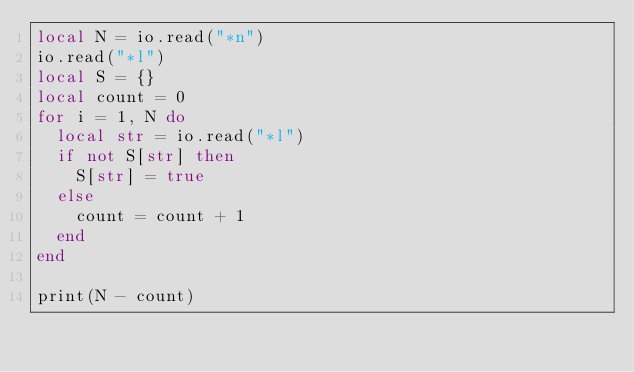Convert code to text. <code><loc_0><loc_0><loc_500><loc_500><_Lua_>local N = io.read("*n")
io.read("*l")
local S = {}
local count = 0
for i = 1, N do
	local str = io.read("*l")
	if not S[str] then
		S[str] = true
	else
		count = count + 1
	end
end

print(N - count)</code> 